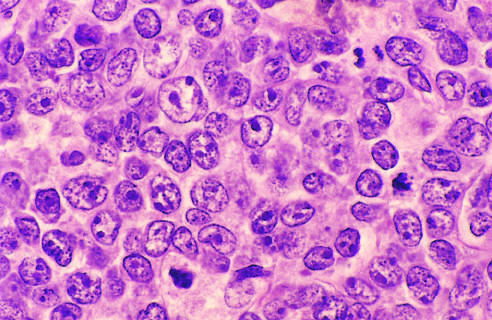how do the tumor cells have large nuclei?
Answer the question using a single word or phrase. With open chromatin and prominent nucleoli 